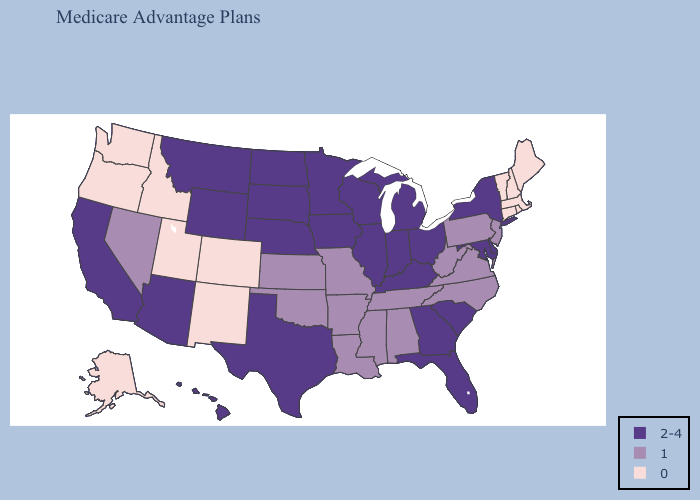Does Wyoming have a higher value than Minnesota?
Short answer required. No. Does Arkansas have the lowest value in the USA?
Quick response, please. No. Among the states that border Georgia , does Florida have the lowest value?
Short answer required. No. Name the states that have a value in the range 0?
Short answer required. Alaska, Colorado, Connecticut, Idaho, Massachusetts, Maine, New Hampshire, New Mexico, Oregon, Rhode Island, Utah, Vermont, Washington. What is the lowest value in the USA?
Give a very brief answer. 0. Name the states that have a value in the range 0?
Quick response, please. Alaska, Colorado, Connecticut, Idaho, Massachusetts, Maine, New Hampshire, New Mexico, Oregon, Rhode Island, Utah, Vermont, Washington. Does Oklahoma have the same value as South Dakota?
Short answer required. No. Name the states that have a value in the range 0?
Quick response, please. Alaska, Colorado, Connecticut, Idaho, Massachusetts, Maine, New Hampshire, New Mexico, Oregon, Rhode Island, Utah, Vermont, Washington. Does the first symbol in the legend represent the smallest category?
Give a very brief answer. No. Does New Hampshire have the highest value in the USA?
Write a very short answer. No. What is the value of Tennessee?
Short answer required. 1. What is the lowest value in states that border Michigan?
Be succinct. 2-4. How many symbols are there in the legend?
Short answer required. 3. What is the value of Delaware?
Keep it brief. 2-4. Which states have the lowest value in the Northeast?
Short answer required. Connecticut, Massachusetts, Maine, New Hampshire, Rhode Island, Vermont. 